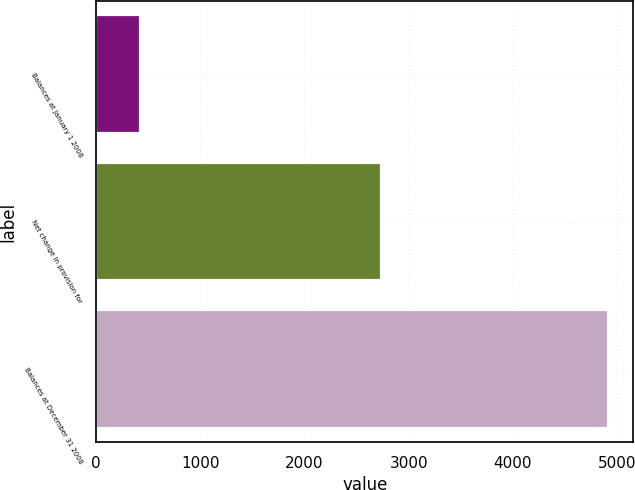Convert chart to OTSL. <chart><loc_0><loc_0><loc_500><loc_500><bar_chart><fcel>Balances at January 1 2008<fcel>Net change in provision for<fcel>Balances at December 31 2008<nl><fcel>420.2<fcel>2737.8<fcel>4911.6<nl></chart> 